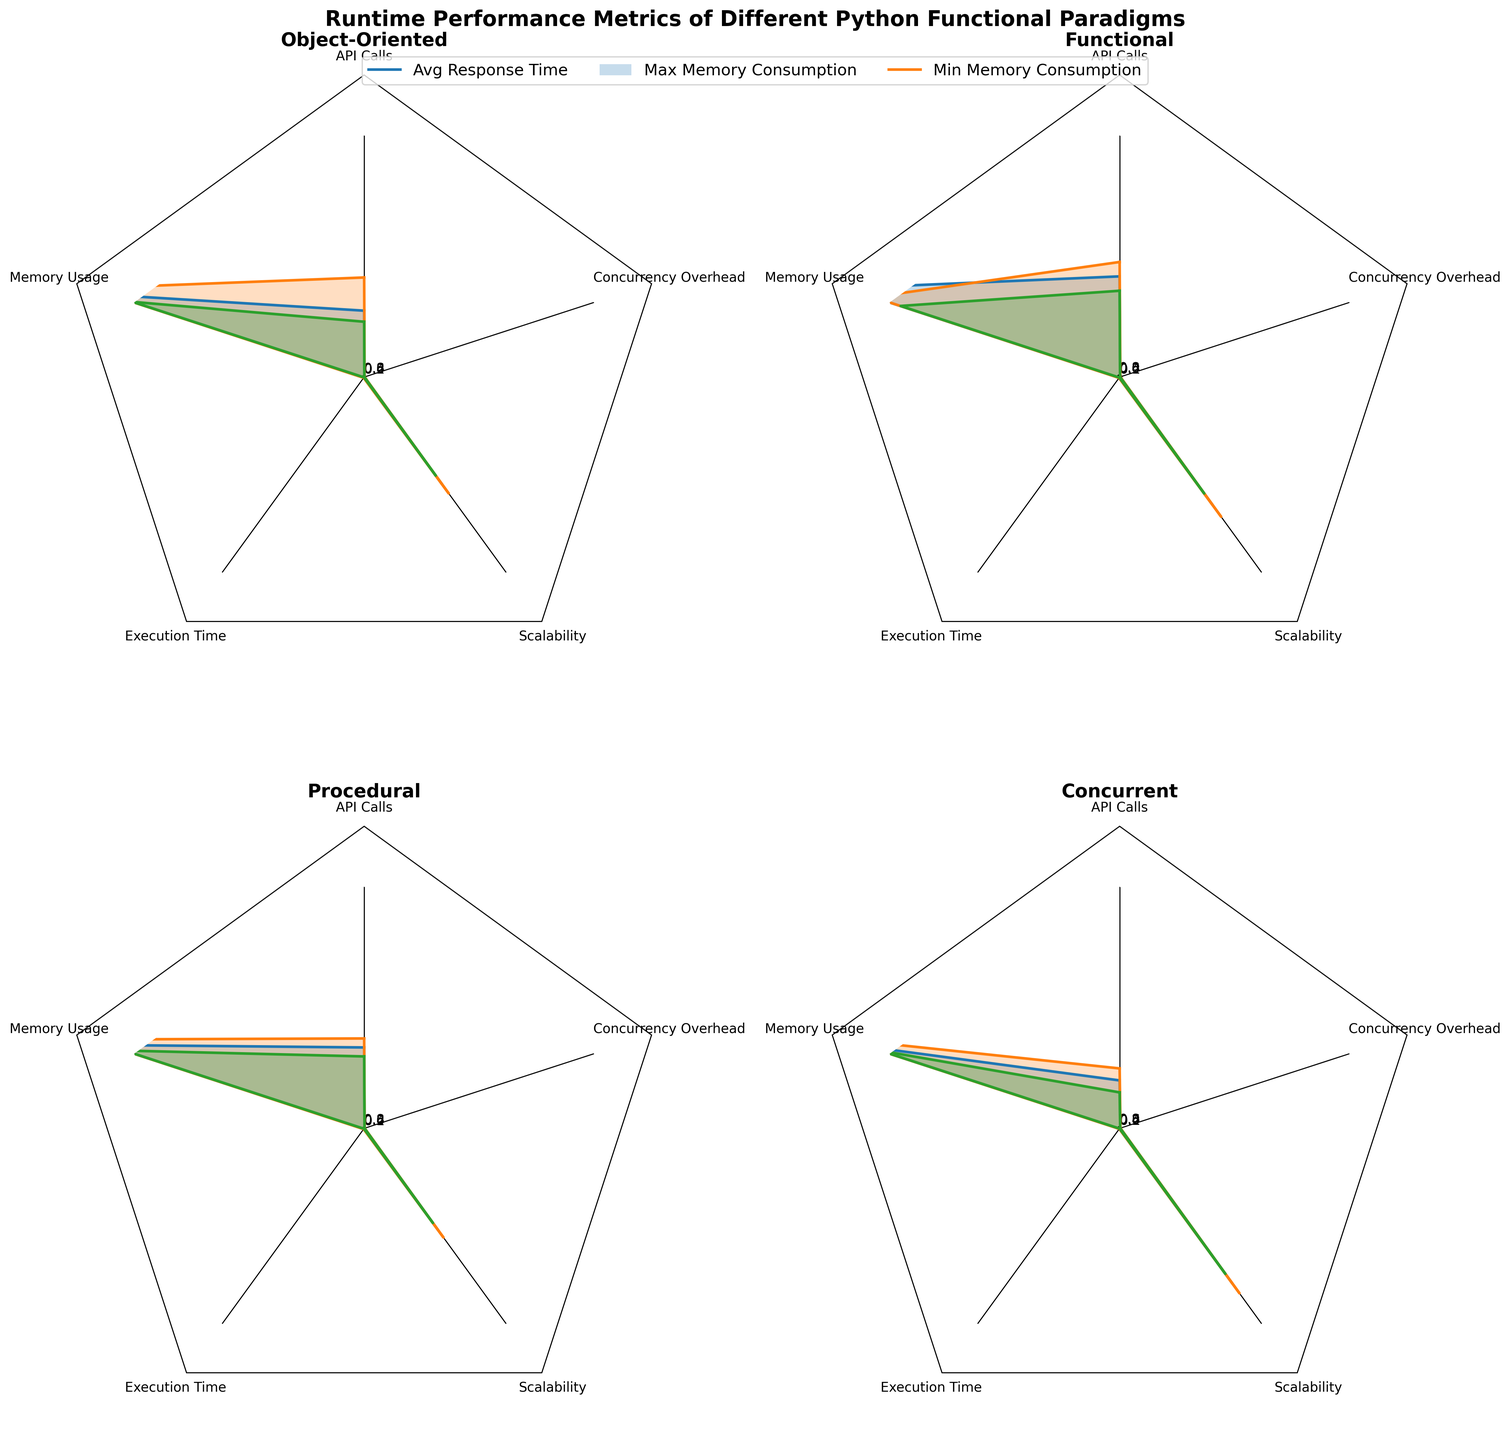What is the title of the figure? The title of the figure is displayed at the top of the overall plot. It reads "Runtime Performance Metrics of Different Python Functional Paradigms".
Answer: Runtime Performance Metrics of Different Python Functional Paradigms Which programming paradigm has the smallest average concurrency overhead? By observing the radar charts, the Concurrent programming paradigm has the smallest average concurrency overhead as it is positioned closest to the center of the axis representing Concurrency Overhead.
Answer: Concurrent How many primary metrics are displayed in each radar chart? Each limb of the radar represents one of the primary metrics. By counting the labels, we can confirm there are five metrics: API Calls, Memory Usage, Execution Time, Scalability, and Concurrency Overhead.
Answer: 5 Which paradigm has the highest max memory consumption? By comparing the “Max Memory Consumption” metric on all radar charts, Procedural programming clearly has the highest max memory consumption as evidenced by the largest distance from the center on the Memory Usage axis.
Answer: Procedural Between Object-Oriented and Functional paradigms, which one has better (lower) average execution time? The radar arm representing "Execution Time" can be compared between Object-Oriented and Functional paradigms. The Functional paradigm is closer to the center, suggesting it has a better (lower) execution time.
Answer: Functional Which paradigm has the best scalability? Scalability is denoted as one of the axes in the radar chart. The Concurrent paradigm ranks highest in scalability since it extends farthest on the Scalability axis in the corresponding subplot.
Answer: Concurrent Compare the concurrency overhead between Functional and Procedural paradigms. Which one is higher? The radar charts for both Functional and Procedural can be compared on the Concurrency Overhead axis. It is found that Procedural programming lies further out on this axis, indicating a higher concurrency overhead.
Answer: Procedural What is the average API Calls for the Object-Oriented paradigm? The Object-Oriented paradigm has three data points for API Calls: 30, 45, and 25. The average is calculated as (30+45+25)/3 = 33.33.
Answer: 33.33 Which metric does Object-Oriented programming excel at the most (i.e., has the best value in terms of performance)? Object-Oriented programming excels the most in "Min Memory Consumption" as it has its closest proximity to the center on this axis compared to other metrics, suggesting better performance.
Answer: Min Memory Consumption 